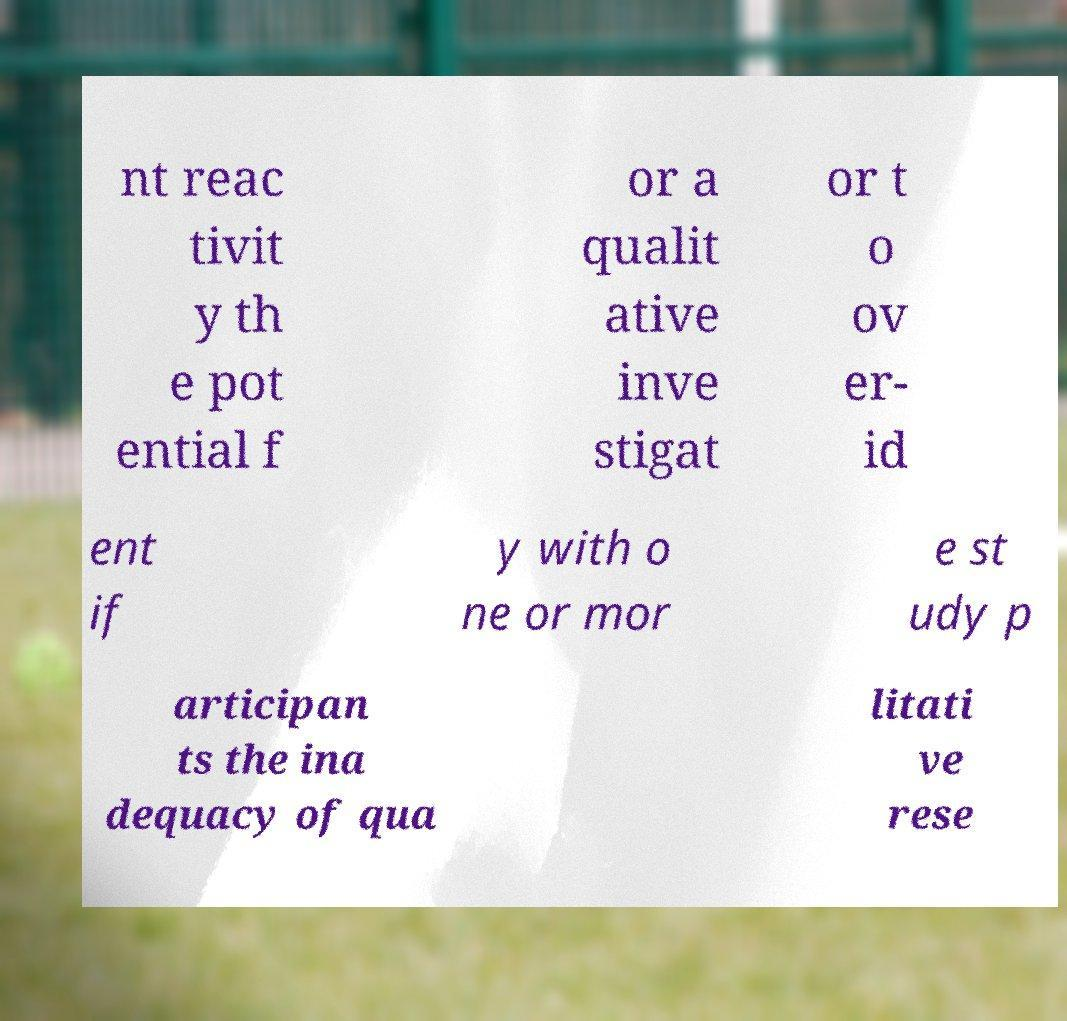Could you assist in decoding the text presented in this image and type it out clearly? nt reac tivit y th e pot ential f or a qualit ative inve stigat or t o ov er- id ent if y with o ne or mor e st udy p articipan ts the ina dequacy of qua litati ve rese 